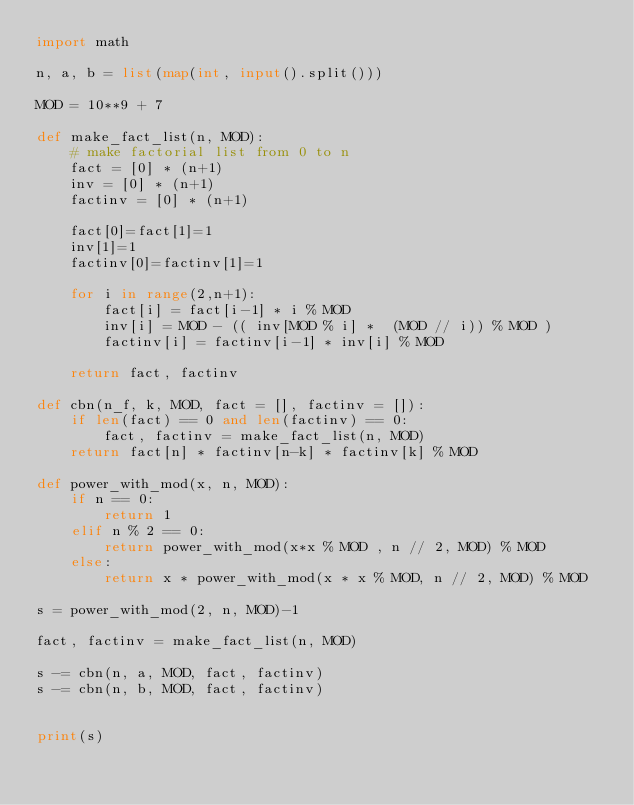<code> <loc_0><loc_0><loc_500><loc_500><_Python_>import math

n, a, b = list(map(int, input().split()))

MOD = 10**9 + 7

def make_fact_list(n, MOD):
    # make factorial list from 0 to n
    fact = [0] * (n+1)
    inv = [0] * (n+1)
    factinv = [0] * (n+1)

    fact[0]=fact[1]=1
    inv[1]=1
    factinv[0]=factinv[1]=1

    for i in range(2,n+1):
        fact[i] = fact[i-1] * i % MOD
        inv[i] = MOD - (( inv[MOD % i] *  (MOD // i)) % MOD )
        factinv[i] = factinv[i-1] * inv[i] % MOD
    
    return fact, factinv

def cbn(n_f, k, MOD, fact = [], factinv = []):
    if len(fact) == 0 and len(factinv) == 0:
        fact, factinv = make_fact_list(n, MOD)
    return fact[n] * factinv[n-k] * factinv[k] % MOD

def power_with_mod(x, n, MOD):
    if n == 0:
        return 1
    elif n % 2 == 0:
        return power_with_mod(x*x % MOD , n // 2, MOD) % MOD
    else:
        return x * power_with_mod(x * x % MOD, n // 2, MOD) % MOD

s = power_with_mod(2, n, MOD)-1

fact, factinv = make_fact_list(n, MOD)

s -= cbn(n, a, MOD, fact, factinv)
s -= cbn(n, b, MOD, fact, factinv)


print(s)</code> 